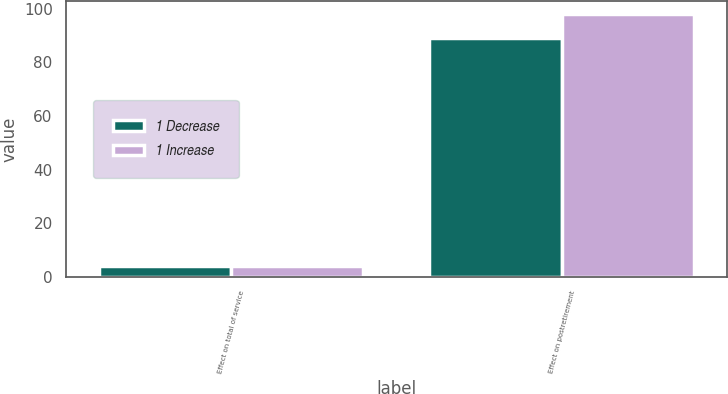Convert chart. <chart><loc_0><loc_0><loc_500><loc_500><stacked_bar_chart><ecel><fcel>Effect on total of service<fcel>Effect on postretirement<nl><fcel>1 Decrease<fcel>4<fcel>89<nl><fcel>1 Increase<fcel>4<fcel>98<nl></chart> 